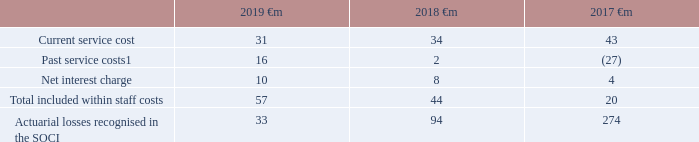Charges made to the consolidated income statement and consolidated statement of comprehensive income (‘SOCI’) on the basis of the assumptions stated above are:
Note: 1 Following a High Court judgement on 21 October 2018 which concluded that defined benefit schemes should equalise pension benefits for men and women in relation to guaranteed minimum pension (‘GMP’) benefits the Group has recorded a pre-tax past service cost of €16 million (£14 million) in the year ended 31 March 2019.
Which financial items listed in the table are included within staff costs? Current service cost, past service costs, net interest charge. Which financial years' information is shown in the table? 2017, 2018, 2019. How much is the 2019 current service cost?
Answer scale should be: million. 31. What is the 2019 average actuarial losses recognised in the SOCI ?
Answer scale should be: million. (33+94)/2
Answer: 63.5. What is the 2018 average actuarial losses recognised in the SOCI ?
Answer scale should be: million. (94+274)/2
Answer: 184. What is the change between 2018 and 2019 average actuarial losses recognised in the SOCI?
Answer scale should be: million. [(33+94)/2] - [(94+274)/2]
Answer: -120.5. 